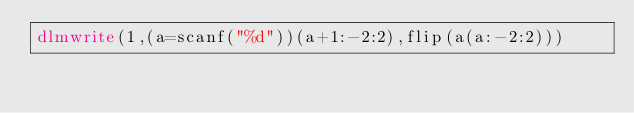<code> <loc_0><loc_0><loc_500><loc_500><_Octave_>dlmwrite(1,(a=scanf("%d"))(a+1:-2:2),flip(a(a:-2:2)))</code> 